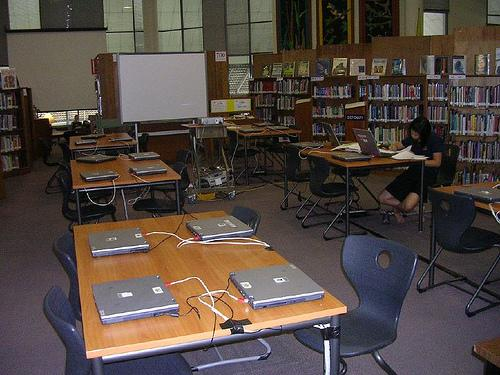Who owns those laptops? Please explain your reasoning. library. The library is in a school and the school gives them the computers. 